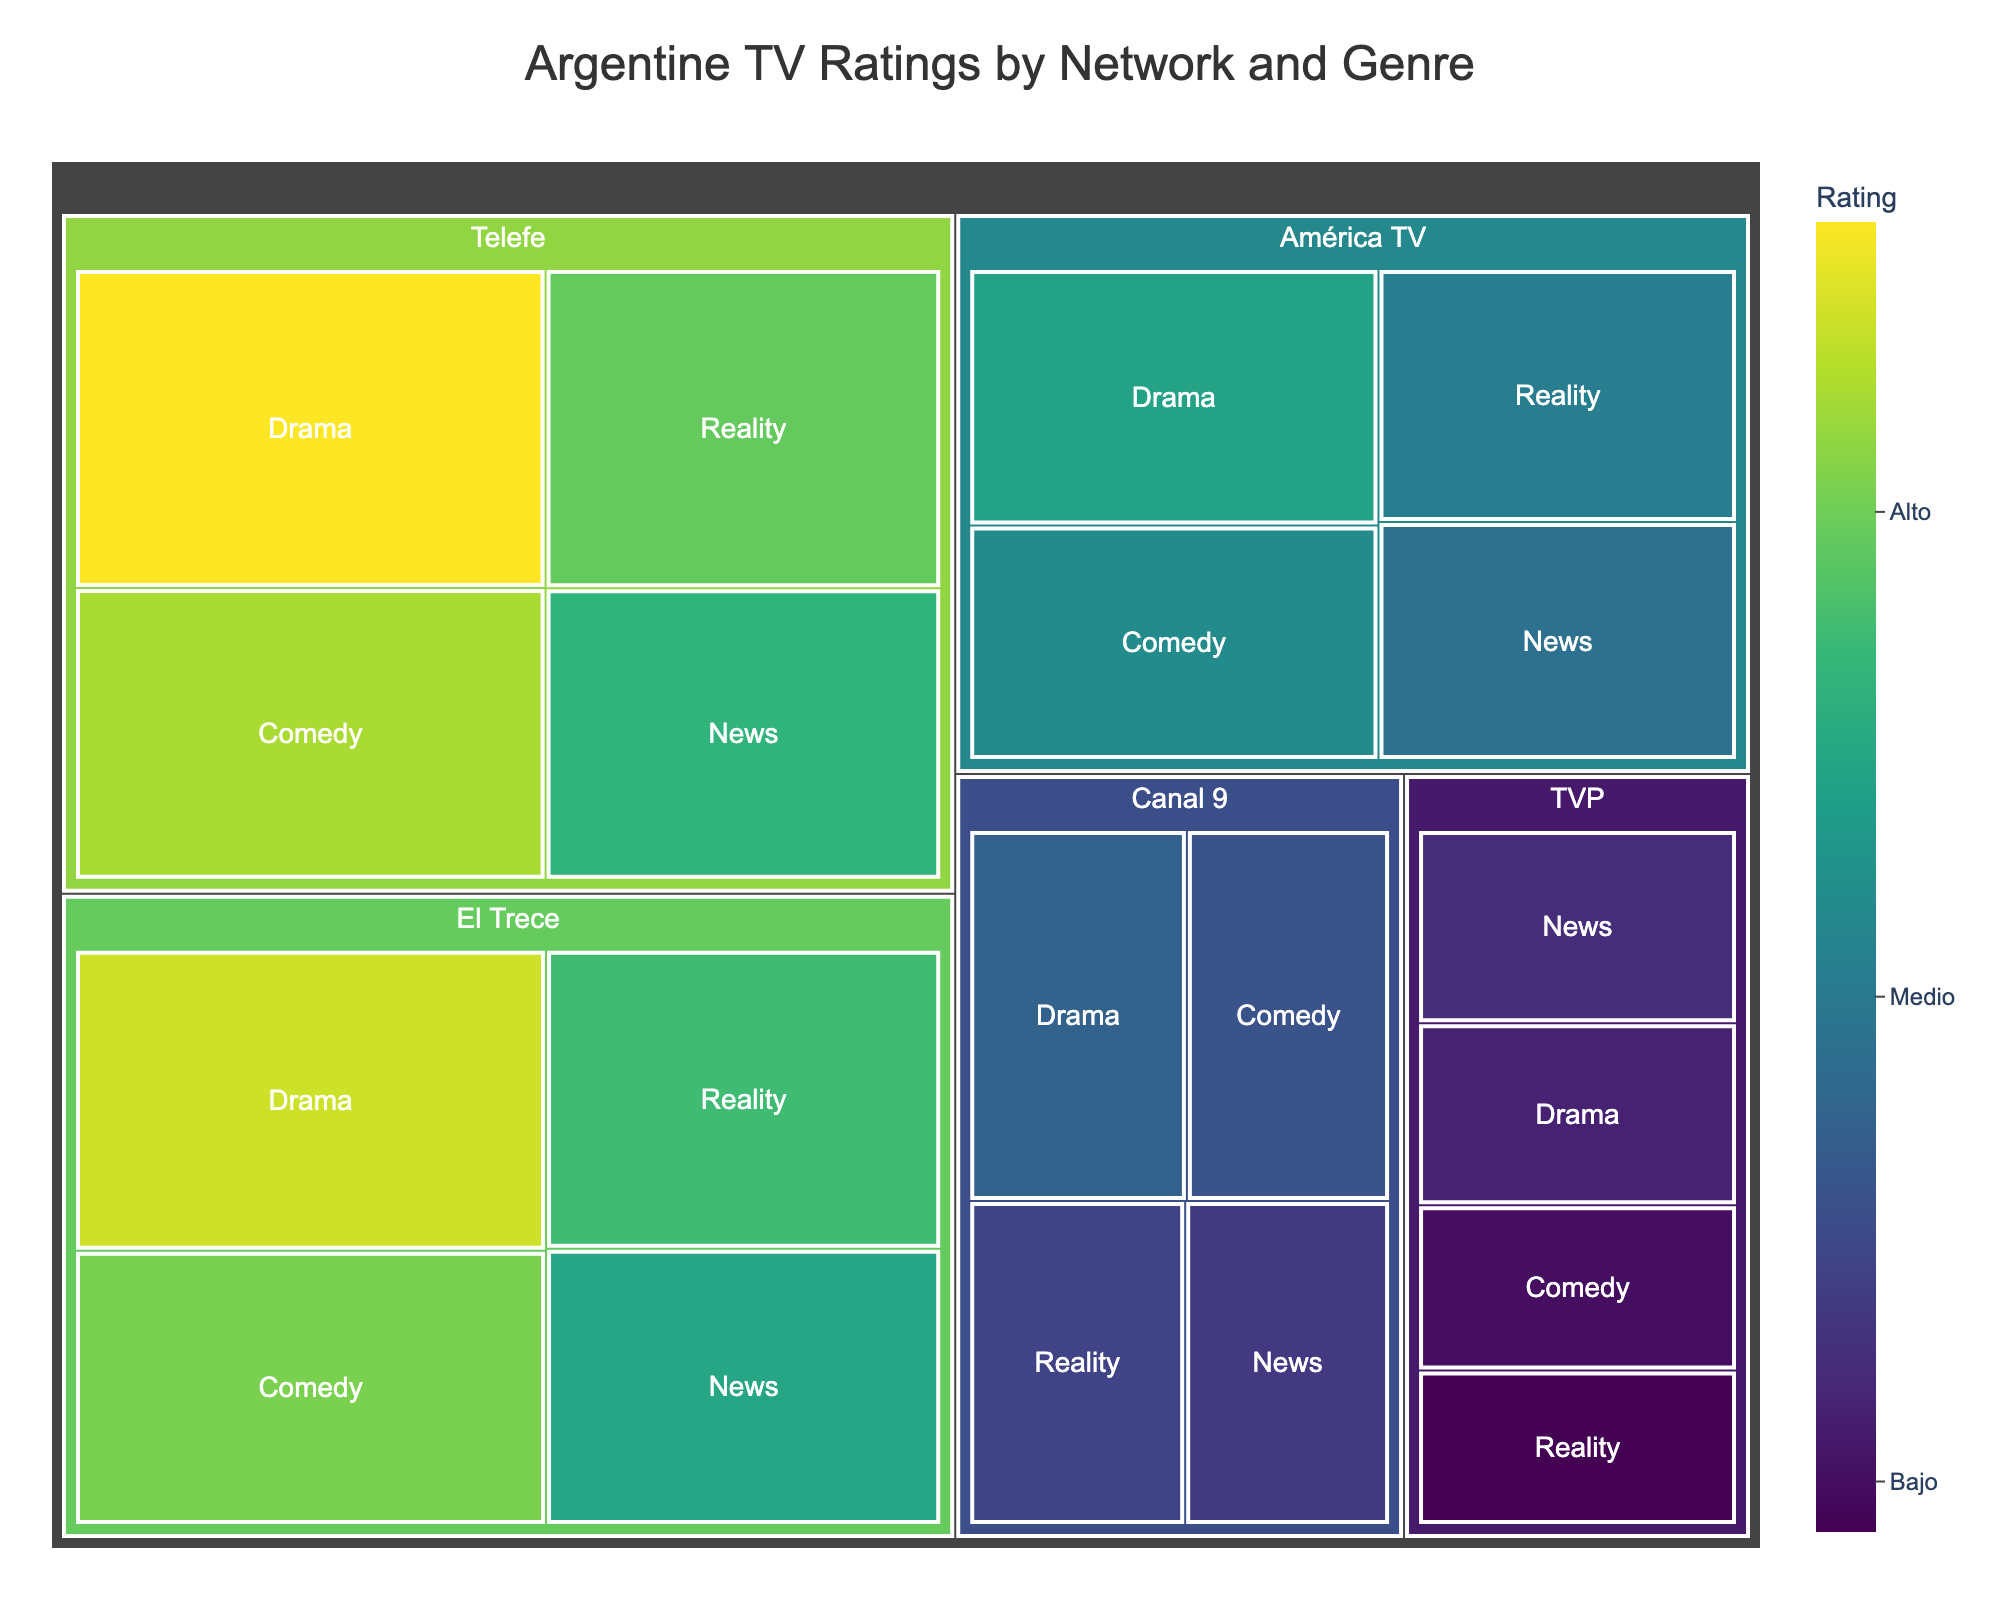What's the title of the figure? The title is located at the top of the figure, which summarizes the content being presented.
Answer: Argentine TV Ratings by Network and Genre Which network has the highest rating for the Drama genre? Identify the Drama genre under each network and compare their ratings. Telefe has the highest at 8.2.
Answer: Telefe What is the color scale used in the figure? The color scale is described in the color bar on the right side of the figure, indicating the ratings with corresponding colors.
Answer: Viridis Which genre has the lowest average rating across all networks? Calculate the average rating for each genre by summing the ratings of all networks within a genre and dividing by the number of networks. News has the lowest average of (6.3+6.0+4.8+3.7+3.5)/5 = 4.86.
Answer: News How does the rating of Reality shows on El Trece compare to those on América TV? Locate the ratings of Reality shows for both networks and directly compare their values. El Trece has a rating of 6.5 while América TV has 5.1.
Answer: El Trece is higher Which network shows the least variation in ratings across different genres? Calculate the range of ratings (difference between the highest and lowest ratings) for each network. América TV has the range of 5.9-4.8=1.1, the smallest variation compared to others.
Answer: América TV How does the comedy rating of Telefe compare to Canal 9? Identify the comedy ratings for both networks; Telefe has 7.5 and Canal 9 has 4.2. Compare their difference.
Answer: Telefe is higher What are the two highest-rated genres on Telefe? Check the ratings for all genres on Telefe and note the highest two ratings: Drama at 8.2, and Comedy at 7.5.
Answer: Drama, Comedy What is the total combined rating for Drama and News genres on all networks? Sum the ratings for both genres across all networks. Drama total: 8.2+7.8+5.9+4.5+3.3 = 29.7; News total: 6.3+6.0+4.8+3.7+3.5 = 24.3. Combined total: 29.7 + 24.3 = 54.
Answer: 54 Which network appears to focus more on high-rated Drama shows compared to other genres? Compare the Drama ratings with other genres on each network. Telefe has a notably high rating for Drama (8.2) compared to others.
Answer: Telefe 